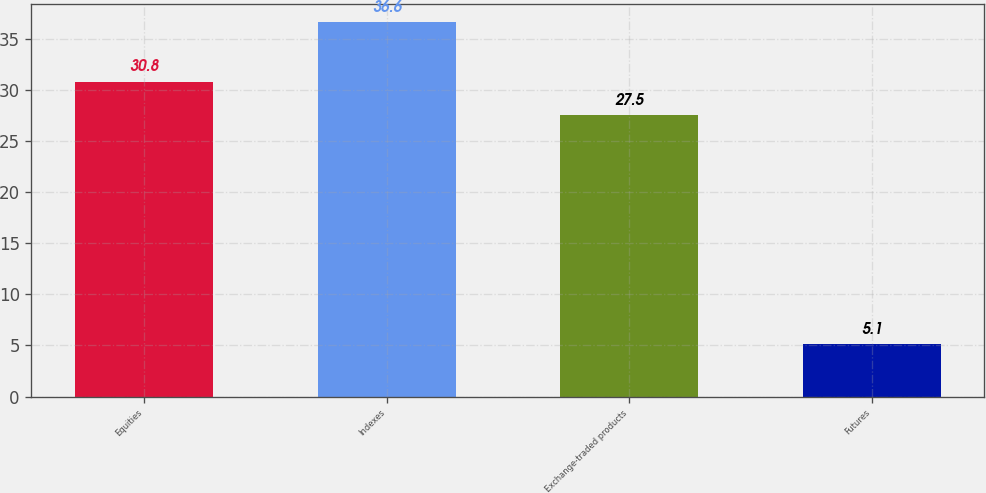Convert chart to OTSL. <chart><loc_0><loc_0><loc_500><loc_500><bar_chart><fcel>Equities<fcel>Indexes<fcel>Exchange-traded products<fcel>Futures<nl><fcel>30.8<fcel>36.6<fcel>27.5<fcel>5.1<nl></chart> 